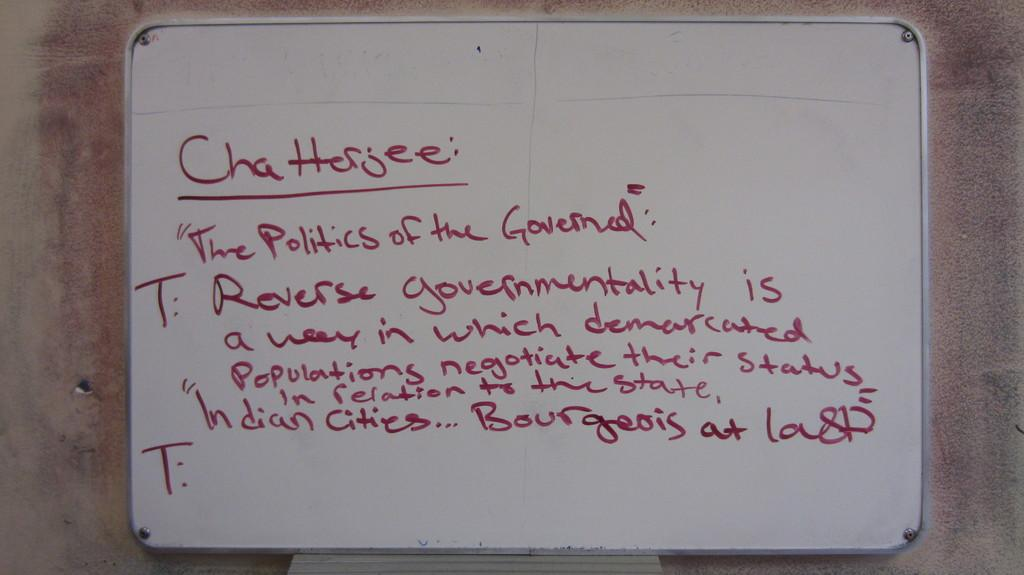<image>
Provide a brief description of the given image. "The Politics of the Governed" is written on the marker board. 